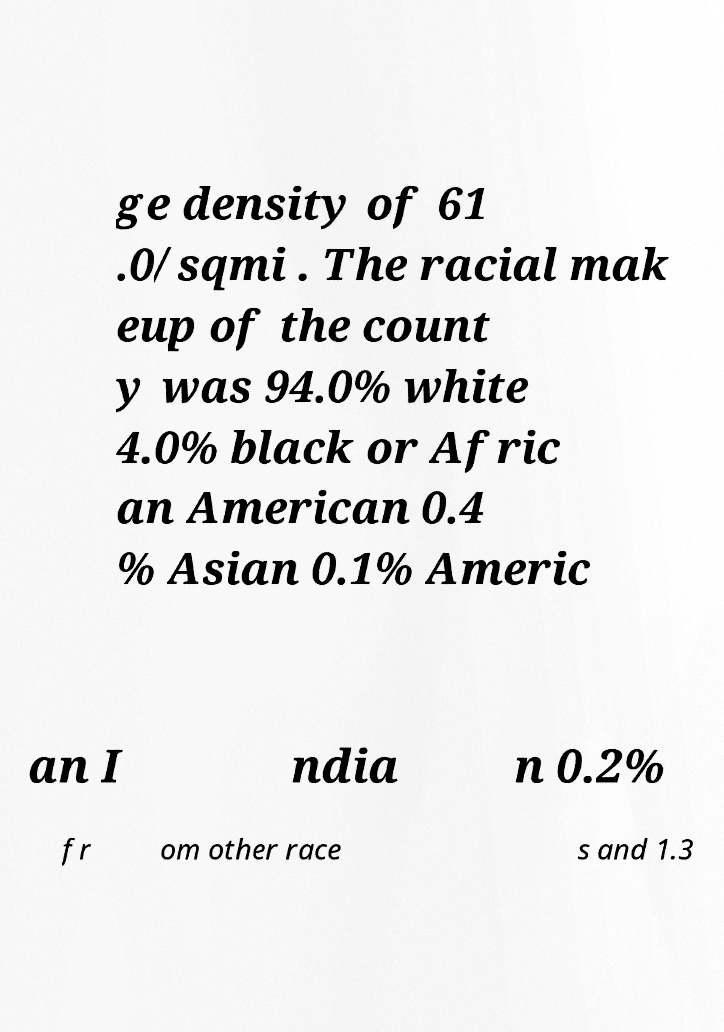Can you accurately transcribe the text from the provided image for me? ge density of 61 .0/sqmi . The racial mak eup of the count y was 94.0% white 4.0% black or Afric an American 0.4 % Asian 0.1% Americ an I ndia n 0.2% fr om other race s and 1.3 